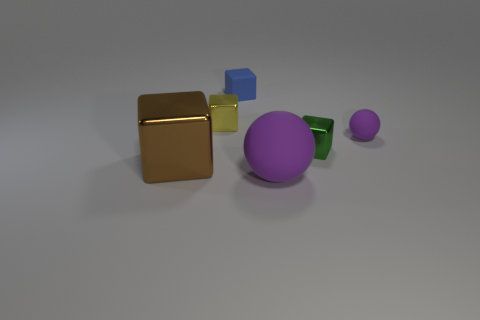There is a small yellow thing that is made of the same material as the brown thing; what is its shape?
Provide a short and direct response. Cube. What size is the thing that is behind the tiny metallic block to the left of the tiny blue block?
Provide a succinct answer. Small. What shape is the large matte thing?
Make the answer very short. Sphere. How many tiny things are purple spheres or brown spheres?
Your answer should be very brief. 1. What size is the yellow metallic thing that is the same shape as the green thing?
Provide a short and direct response. Small. How many things are both in front of the yellow shiny cube and right of the brown block?
Ensure brevity in your answer.  3. Is the shape of the tiny yellow thing the same as the green metal thing behind the big brown object?
Offer a terse response. Yes. Are there more small objects on the right side of the big rubber sphere than small red shiny blocks?
Ensure brevity in your answer.  Yes. Are there fewer tiny metal cubes that are on the left side of the big purple sphere than large cyan rubber blocks?
Provide a short and direct response. No. How many big metallic objects are the same color as the big matte object?
Offer a terse response. 0. 